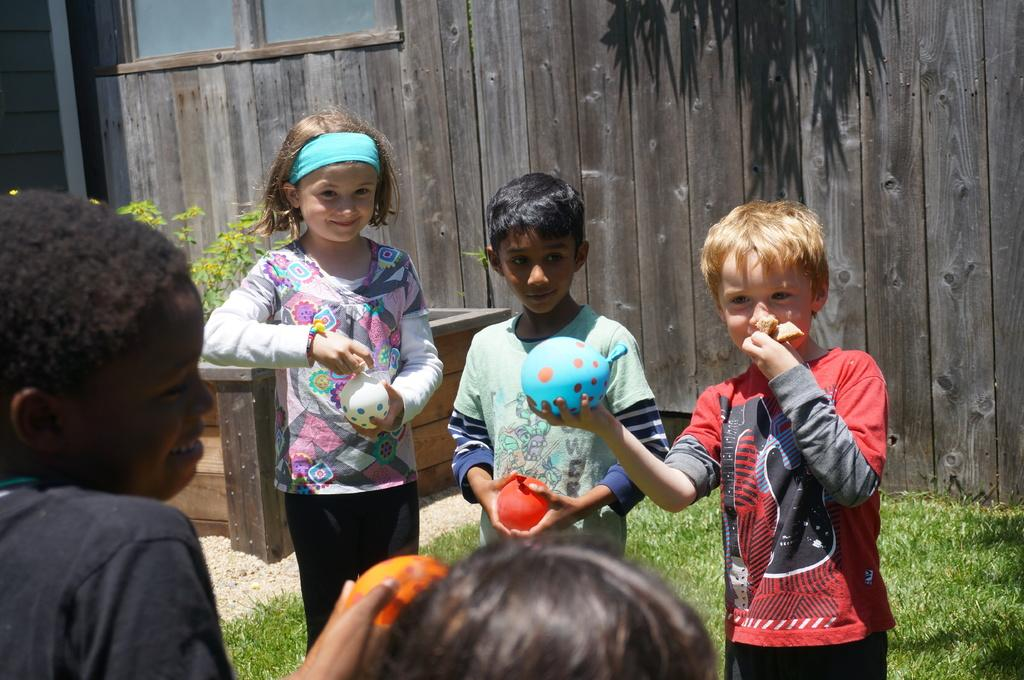Who is present in the image? There are children in the image. What are the children doing in the image? The children are standing on the ground and holding balloons in their hands. What can be seen in the background of the image? There are plants and walls in the background of the image. What type of scene is being depicted in the image? The image does not depict a specific scene; it simply shows children standing on the ground and holding balloons. Can you see any cracks in the walls in the image? There is no mention of any cracks in the walls in the provided facts, so it cannot be determined from the image. 